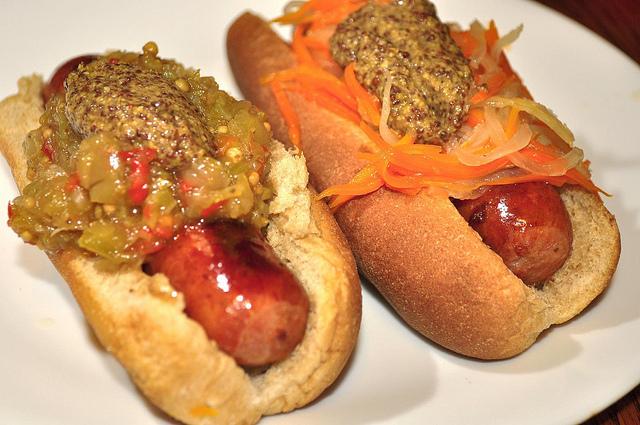What kind of food is this?
Short answer required. Hot dog. Where are the hot dogs?
Be succinct. Plate. What color is the plate?
Write a very short answer. White. 